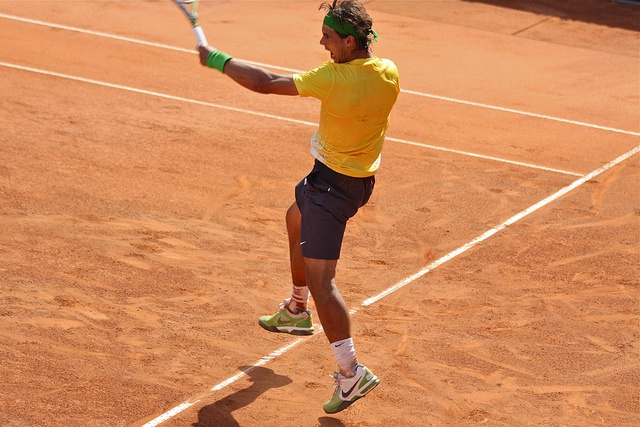Describe the objects in this image and their specific colors. I can see people in tan, black, maroon, and orange tones and tennis racket in tan, lightgray, and gray tones in this image. 